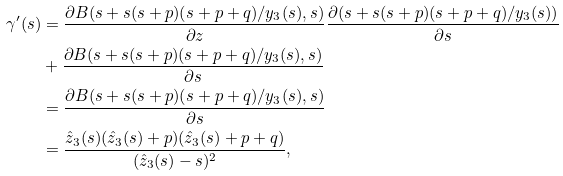Convert formula to latex. <formula><loc_0><loc_0><loc_500><loc_500>\gamma ^ { \prime } ( s ) & = \frac { \partial B ( s + s ( s + p ) ( s + p + q ) / y _ { 3 } ( s ) , s ) } { \partial z } \frac { \partial ( s + s ( s + p ) ( s + p + q ) / y _ { 3 } ( s ) ) } { \partial s } \\ & + \frac { \partial B ( s + s ( s + p ) ( s + p + q ) / y _ { 3 } ( s ) , s ) } { \partial s } \\ & = \frac { \partial B ( s + s ( s + p ) ( s + p + q ) / y _ { 3 } ( s ) , s ) } { \partial s } \\ & = \frac { \hat { z } _ { 3 } ( s ) ( \hat { z } _ { 3 } ( s ) + p ) ( \hat { z } _ { 3 } ( s ) + p + q ) } { ( \hat { z } _ { 3 } ( s ) - s ) ^ { 2 } } ,</formula> 